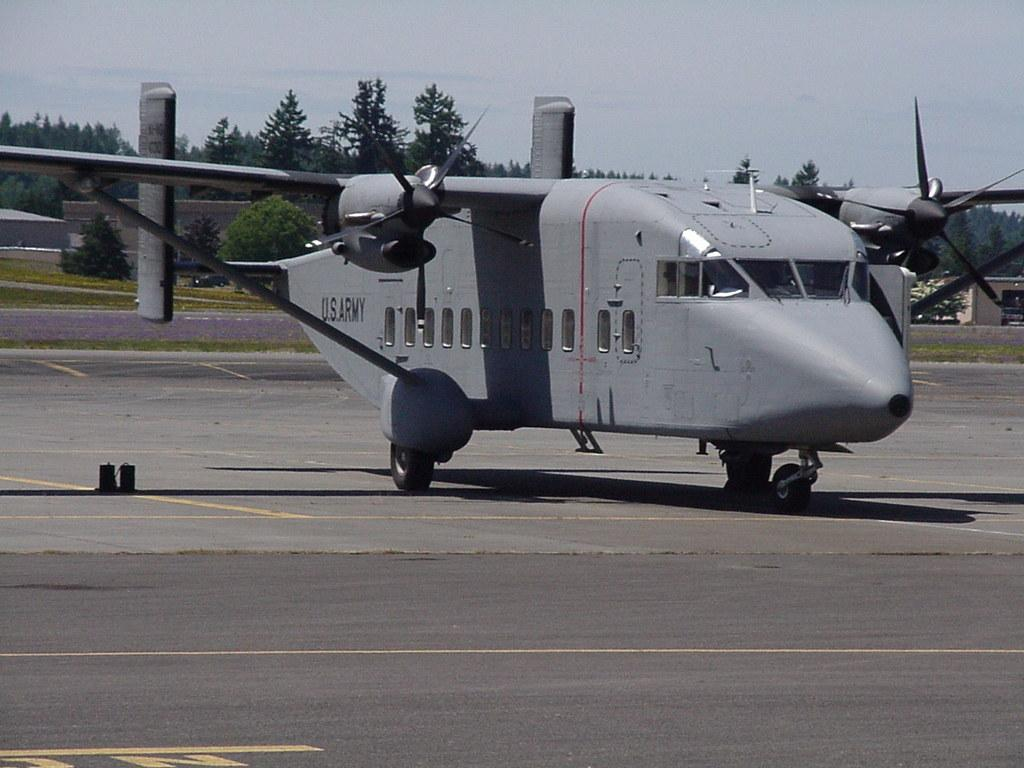What is the main subject of the image? The main subject of the image is a huge aircraft. What colors are used to paint the aircraft? The aircraft is grey and black in color. Where is the aircraft located in the image? The aircraft is on the ground. What can be seen in the background of the image? There are trees and the sky visible in the background of the image. What is the color of the trees in the image? The trees are green in color. What type of chess move can be seen being performed by the doctor in the image? There is no doctor or chess move present in the image; it features a huge aircraft on the ground with green trees and a sky in the background. 